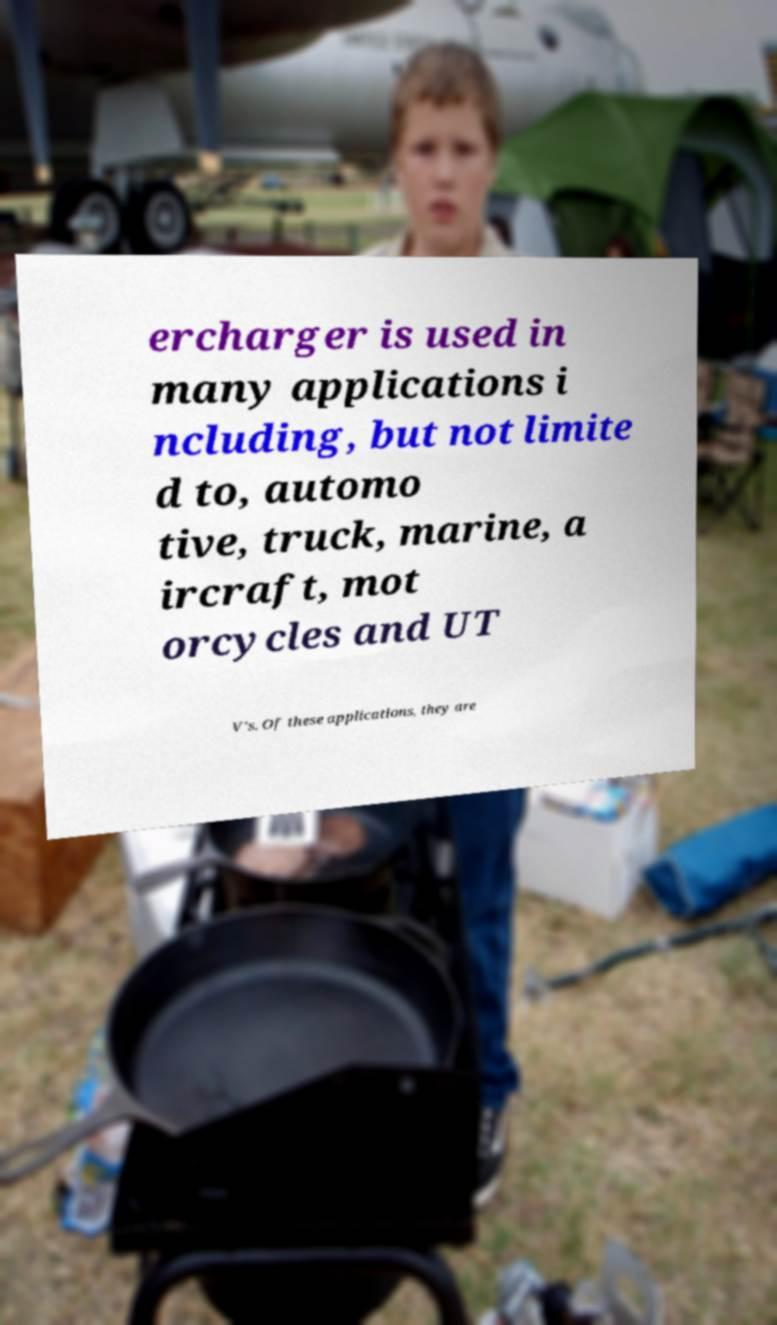What messages or text are displayed in this image? I need them in a readable, typed format. ercharger is used in many applications i ncluding, but not limite d to, automo tive, truck, marine, a ircraft, mot orcycles and UT V's. Of these applications, they are 